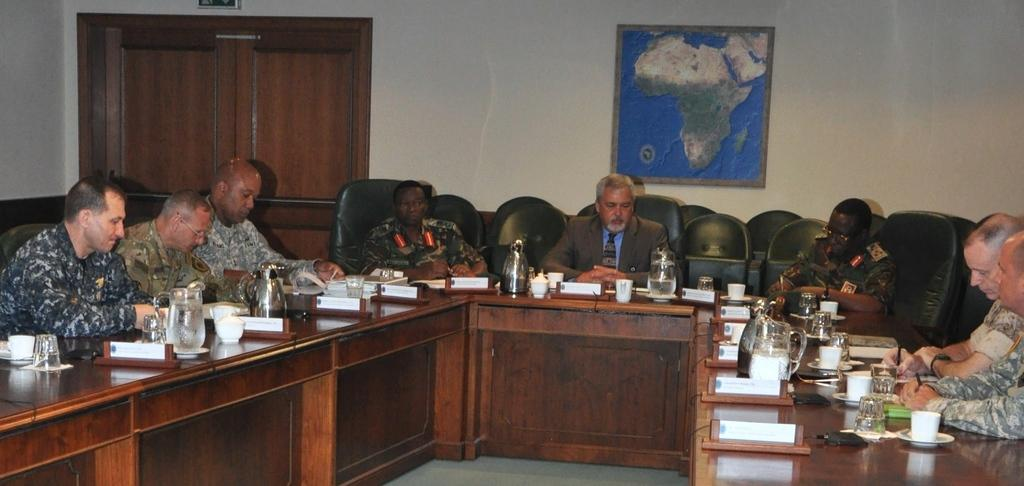What is the color of the wall in the image? The wall in the image is white. What can be seen hanging on the wall? There is a photo frame hanging on the wall in the image. What are the people in the image doing? The people in the image are sitting on chairs. What furniture is present in the image? There is a table in the image. What items can be seen on the table? There are mugs, glasses, cups, and plates on the table. What is the texture of the bit in the image? There is no bit present in the image. How many visitors are visible in the image? There is no mention of visitors in the image; it only shows people sitting on chairs and items on a table. 